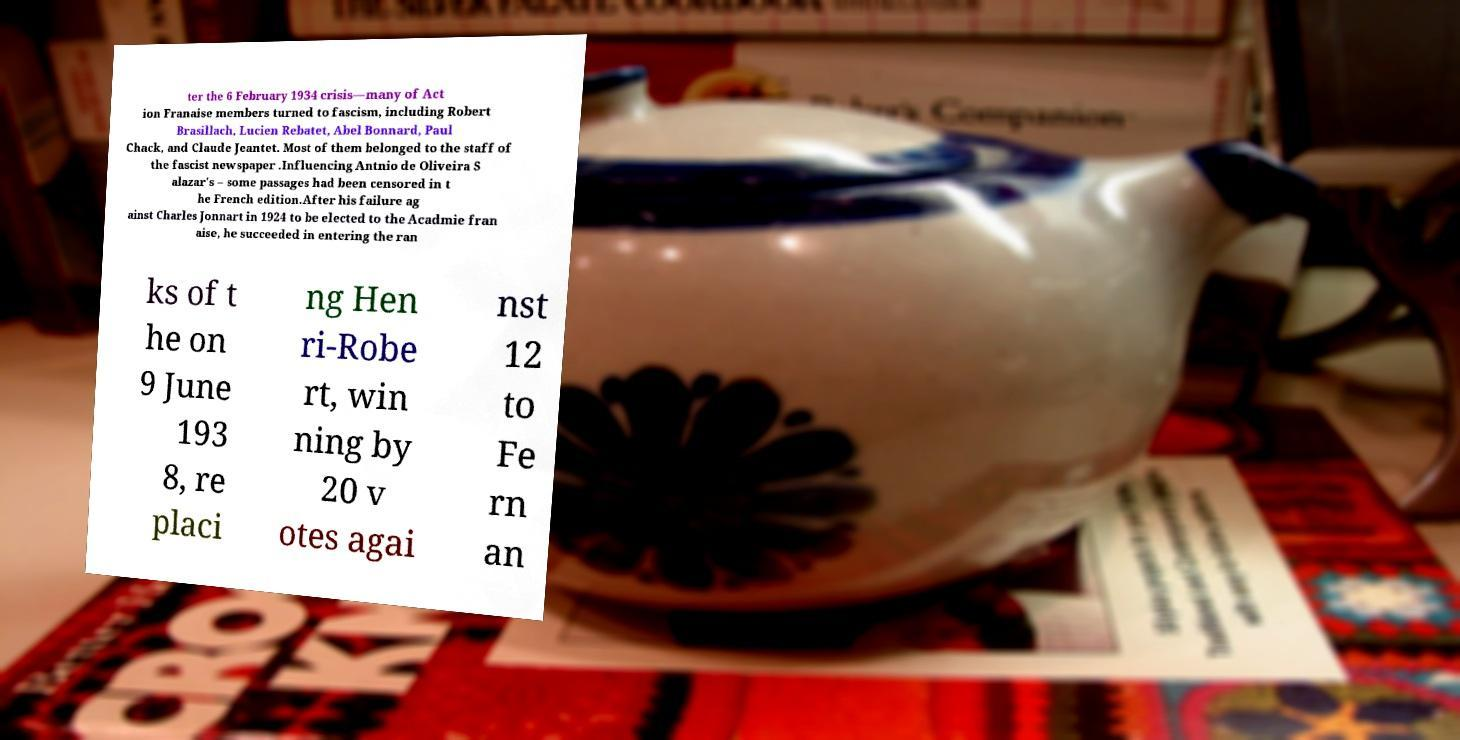Please identify and transcribe the text found in this image. ter the 6 February 1934 crisis—many of Act ion Franaise members turned to fascism, including Robert Brasillach, Lucien Rebatet, Abel Bonnard, Paul Chack, and Claude Jeantet. Most of them belonged to the staff of the fascist newspaper .Influencing Antnio de Oliveira S alazar's – some passages had been censored in t he French edition.After his failure ag ainst Charles Jonnart in 1924 to be elected to the Acadmie fran aise, he succeeded in entering the ran ks of t he on 9 June 193 8, re placi ng Hen ri-Robe rt, win ning by 20 v otes agai nst 12 to Fe rn an 